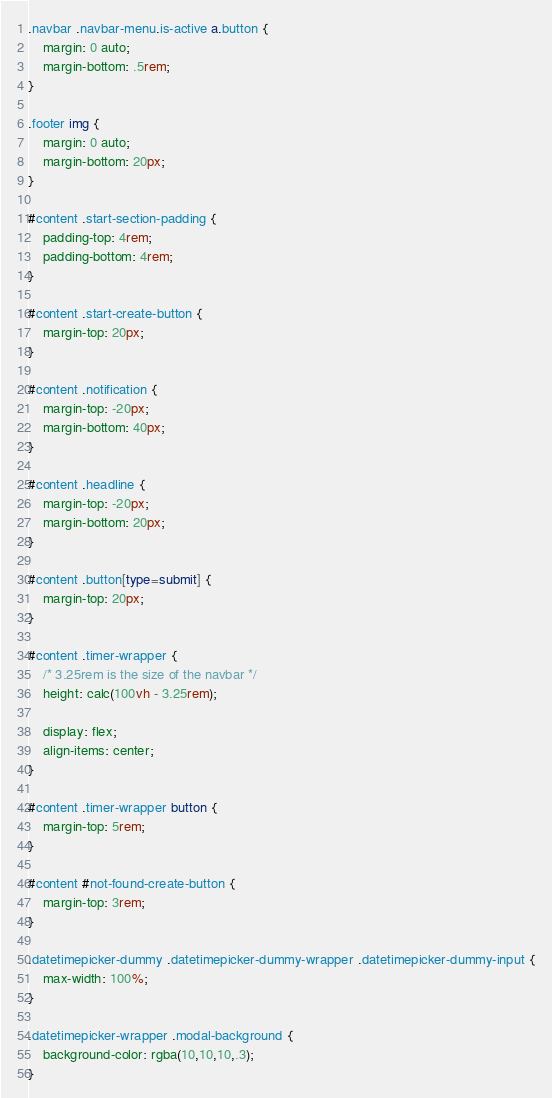<code> <loc_0><loc_0><loc_500><loc_500><_CSS_>.navbar .navbar-menu.is-active a.button {
    margin: 0 auto;
    margin-bottom: .5rem;
}

.footer img {
    margin: 0 auto;
    margin-bottom: 20px;
}

#content .start-section-padding {
    padding-top: 4rem;
    padding-bottom: 4rem;
}

#content .start-create-button {
    margin-top: 20px;
}

#content .notification {
    margin-top: -20px;
    margin-bottom: 40px;
}

#content .headline {
    margin-top: -20px;
    margin-bottom: 20px;
}

#content .button[type=submit] {
    margin-top: 20px;
}

#content .timer-wrapper {
    /* 3.25rem is the size of the navbar */
    height: calc(100vh - 3.25rem);

    display: flex;
    align-items: center;
}

#content .timer-wrapper button {
    margin-top: 5rem;
}

#content #not-found-create-button {
    margin-top: 3rem;
}

.datetimepicker-dummy .datetimepicker-dummy-wrapper .datetimepicker-dummy-input {
    max-width: 100%;
}

.datetimepicker-wrapper .modal-background {
    background-color: rgba(10,10,10,.3);
}
</code> 